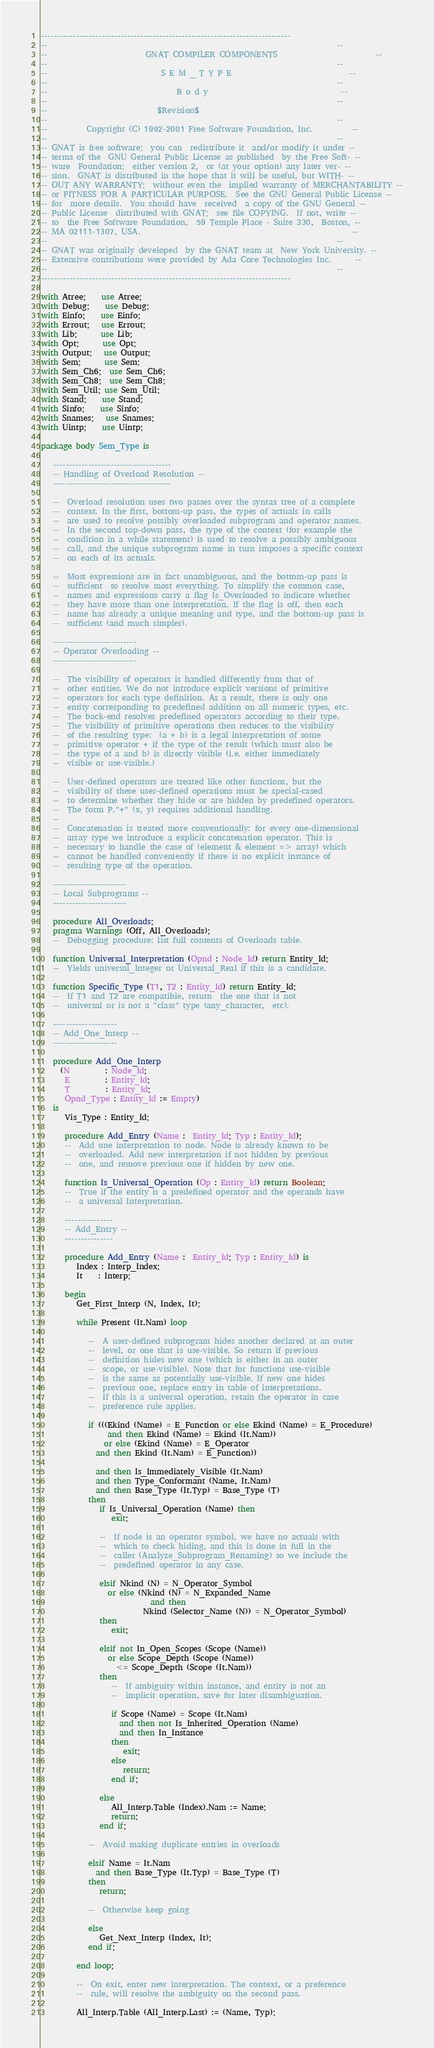Convert code to text. <code><loc_0><loc_0><loc_500><loc_500><_Ada_>------------------------------------------------------------------------------
--                                                                          --
--                         GNAT COMPILER COMPONENTS                         --
--                                                                          --
--                             S E M _ T Y P E                              --
--                                                                          --
--                                 B o d y                                  --
--                                                                          --
--                            $Revision$
--                                                                          --
--          Copyright (C) 1992-2001 Free Software Foundation, Inc.          --
--                                                                          --
-- GNAT is free software;  you can  redistribute it  and/or modify it under --
-- terms of the  GNU General Public License as published  by the Free Soft- --
-- ware  Foundation;  either version 2,  or (at your option) any later ver- --
-- sion.  GNAT is distributed in the hope that it will be useful, but WITH- --
-- OUT ANY WARRANTY;  without even the  implied warranty of MERCHANTABILITY --
-- or FITNESS FOR A PARTICULAR PURPOSE.  See the GNU General Public License --
-- for  more details.  You should have  received  a copy of the GNU General --
-- Public License  distributed with GNAT;  see file COPYING.  If not, write --
-- to  the Free Software Foundation,  59 Temple Place - Suite 330,  Boston, --
-- MA 02111-1307, USA.                                                      --
--                                                                          --
-- GNAT was originally developed  by the GNAT team at  New York University. --
-- Extensive contributions were provided by Ada Core Technologies Inc.      --
--                                                                          --
------------------------------------------------------------------------------

with Atree;    use Atree;
with Debug;    use Debug;
with Einfo;    use Einfo;
with Errout;   use Errout;
with Lib;      use Lib;
with Opt;      use Opt;
with Output;   use Output;
with Sem;      use Sem;
with Sem_Ch6;  use Sem_Ch6;
with Sem_Ch8;  use Sem_Ch8;
with Sem_Util; use Sem_Util;
with Stand;    use Stand;
with Sinfo;    use Sinfo;
with Snames;   use Snames;
with Uintp;    use Uintp;

package body Sem_Type is

   -------------------------------------
   -- Handling of Overload Resolution --
   -------------------------------------

   --  Overload resolution uses two passes over the syntax tree of a complete
   --  context. In the first, bottom-up pass, the types of actuals in calls
   --  are used to resolve possibly overloaded subprogram and operator names.
   --  In the second top-down pass, the type of the context (for example the
   --  condition in a while statement) is used to resolve a possibly ambiguous
   --  call, and the unique subprogram name in turn imposes a specific context
   --  on each of its actuals.

   --  Most expressions are in fact unambiguous, and the bottom-up pass is
   --  sufficient  to resolve most everything. To simplify the common case,
   --  names and expressions carry a flag Is_Overloaded to indicate whether
   --  they have more than one interpretation. If the flag is off, then each
   --  name has already a unique meaning and type, and the bottom-up pass is
   --  sufficient (and much simpler).

   --------------------------
   -- Operator Overloading --
   --------------------------

   --  The visibility of operators is handled differently from that of
   --  other entities. We do not introduce explicit versions of primitive
   --  operators for each type definition. As a result, there is only one
   --  entity corresponding to predefined addition on all numeric types, etc.
   --  The back-end resolves predefined operators according to their type.
   --  The visibility of primitive operations then reduces to the visibility
   --  of the resulting type:  (a + b) is a legal interpretation of some
   --  primitive operator + if the type of the result (which must also be
   --  the type of a and b) is directly visible (i.e. either immediately
   --  visible or use-visible.)

   --  User-defined operators are treated like other functions, but the
   --  visibility of these user-defined operations must be special-cased
   --  to determine whether they hide or are hidden by predefined operators.
   --  The form P."+" (x, y) requires additional handling.
   --
   --  Concatenation is treated more conventionally: for every one-dimensional
   --  array type we introduce a explicit concatenation operator. This is
   --  necessary to handle the case of (element & element => array) which
   --  cannot be handled conveniently if there is no explicit instance of
   --  resulting type of the operation.

   -----------------------
   -- Local Subprograms --
   -----------------------

   procedure All_Overloads;
   pragma Warnings (Off, All_Overloads);
   --  Debugging procedure: list full contents of Overloads table.

   function Universal_Interpretation (Opnd : Node_Id) return Entity_Id;
   --  Yields universal_Integer or Universal_Real if this is a candidate.

   function Specific_Type (T1, T2 : Entity_Id) return Entity_Id;
   --  If T1 and T2 are compatible, return  the one that is not
   --  universal or is not a "class" type (any_character,  etc).

   --------------------
   -- Add_One_Interp --
   --------------------

   procedure Add_One_Interp
     (N         : Node_Id;
      E         : Entity_Id;
      T         : Entity_Id;
      Opnd_Type : Entity_Id := Empty)
   is
      Vis_Type : Entity_Id;

      procedure Add_Entry (Name :  Entity_Id; Typ : Entity_Id);
      --  Add one interpretation to node. Node is already known to be
      --  overloaded. Add new interpretation if not hidden by previous
      --  one, and remove previous one if hidden by new one.

      function Is_Universal_Operation (Op : Entity_Id) return Boolean;
      --  True if the entity is a predefined operator and the operands have
      --  a universal Interpretation.

      ---------------
      -- Add_Entry --
      ---------------

      procedure Add_Entry (Name :  Entity_Id; Typ : Entity_Id) is
         Index : Interp_Index;
         It    : Interp;

      begin
         Get_First_Interp (N, Index, It);

         while Present (It.Nam) loop

            --  A user-defined subprogram hides another declared at an outer
            --  level, or one that is use-visible. So return if previous
            --  definition hides new one (which is either in an outer
            --  scope, or use-visible). Note that for functions use-visible
            --  is the same as potentially use-visible. If new one hides
            --  previous one, replace entry in table of interpretations.
            --  If this is a universal operation, retain the operator in case
            --  preference rule applies.

            if (((Ekind (Name) = E_Function or else Ekind (Name) = E_Procedure)
                 and then Ekind (Name) = Ekind (It.Nam))
                or else (Ekind (Name) = E_Operator
              and then Ekind (It.Nam) = E_Function))

              and then Is_Immediately_Visible (It.Nam)
              and then Type_Conformant (Name, It.Nam)
              and then Base_Type (It.Typ) = Base_Type (T)
            then
               if Is_Universal_Operation (Name) then
                  exit;

               --  If node is an operator symbol, we have no actuals with
               --  which to check hiding, and this is done in full in the
               --  caller (Analyze_Subprogram_Renaming) so we include the
               --  predefined operator in any case.

               elsif Nkind (N) = N_Operator_Symbol
                 or else (Nkind (N) = N_Expanded_Name
                            and then
                          Nkind (Selector_Name (N)) = N_Operator_Symbol)
               then
                  exit;

               elsif not In_Open_Scopes (Scope (Name))
                 or else Scope_Depth (Scope (Name))
                   <= Scope_Depth (Scope (It.Nam))
               then
                  --  If ambiguity within instance, and entity is not an
                  --  implicit operation, save for later disambiguation.

                  if Scope (Name) = Scope (It.Nam)
                    and then not Is_Inherited_Operation (Name)
                    and then In_Instance
                  then
                     exit;
                  else
                     return;
                  end if;

               else
                  All_Interp.Table (Index).Nam := Name;
                  return;
               end if;

            --  Avoid making duplicate entries in overloads

            elsif Name = It.Nam
              and then Base_Type (It.Typ) = Base_Type (T)
            then
               return;

            --  Otherwise keep going

            else
               Get_Next_Interp (Index, It);
            end if;

         end loop;

         --  On exit, enter new interpretation. The context, or a preference
         --  rule, will resolve the ambiguity on the second pass.

         All_Interp.Table (All_Interp.Last) := (Name, Typ);</code> 